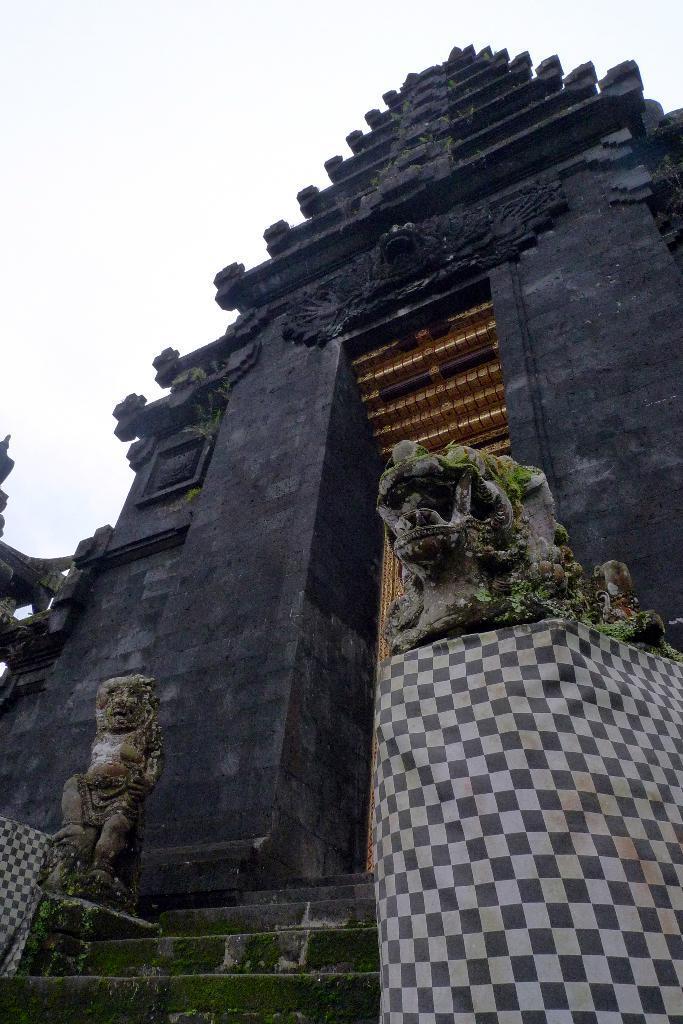Could you give a brief overview of what you see in this image? In this image, we can see a temple with some sculptures. We can also see some statues and some cloth. We can see some stairs and the sky. We can also see some objects on the left. 